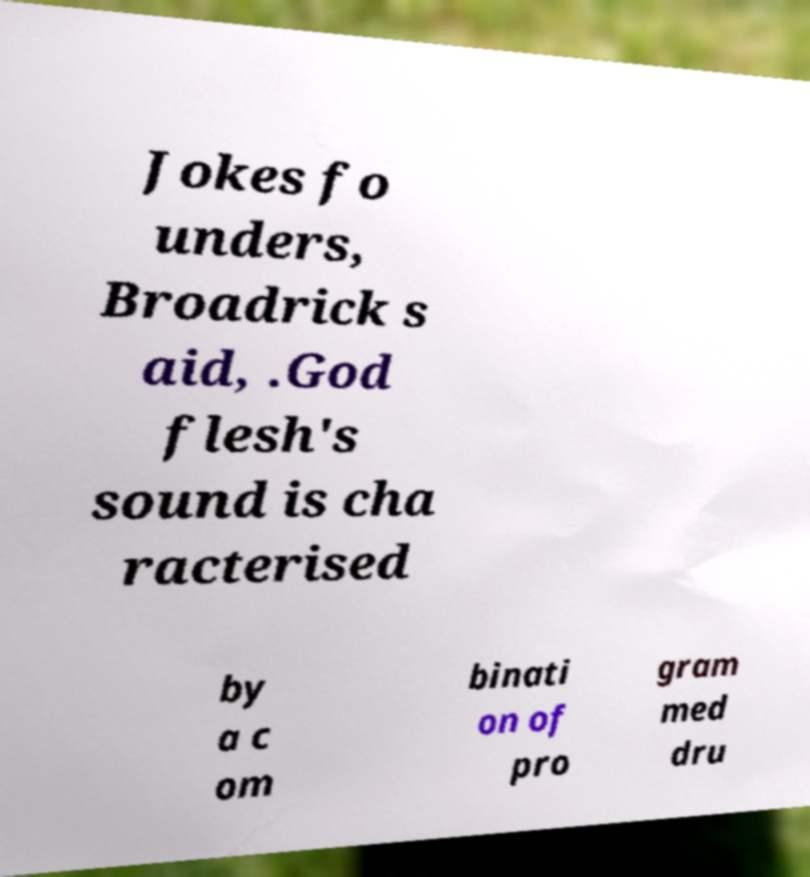Can you read and provide the text displayed in the image?This photo seems to have some interesting text. Can you extract and type it out for me? Jokes fo unders, Broadrick s aid, .God flesh's sound is cha racterised by a c om binati on of pro gram med dru 